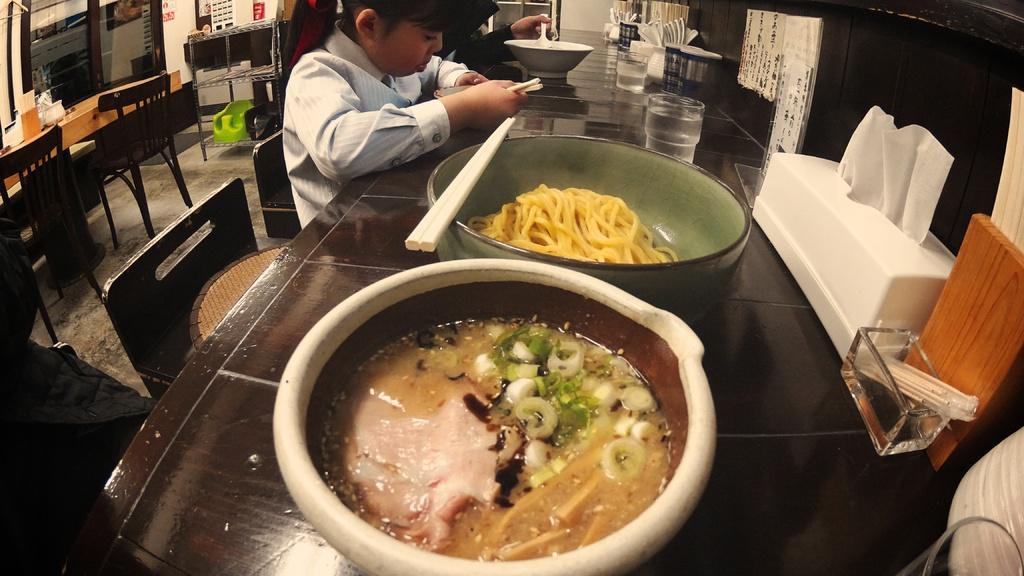Please provide a concise description of this image. In this image there are tables and chairs. There is a girl sitting on the table. In front of her her there is a bowl and she is holding chopsticks in her hand. Behind her there is another person sitting. To the right there is a table. On the table there are bowls, glasses, cutlery, tissues and a glass bowl. In the top left there is a glass door to the wall. Beside the door there is a rack. 